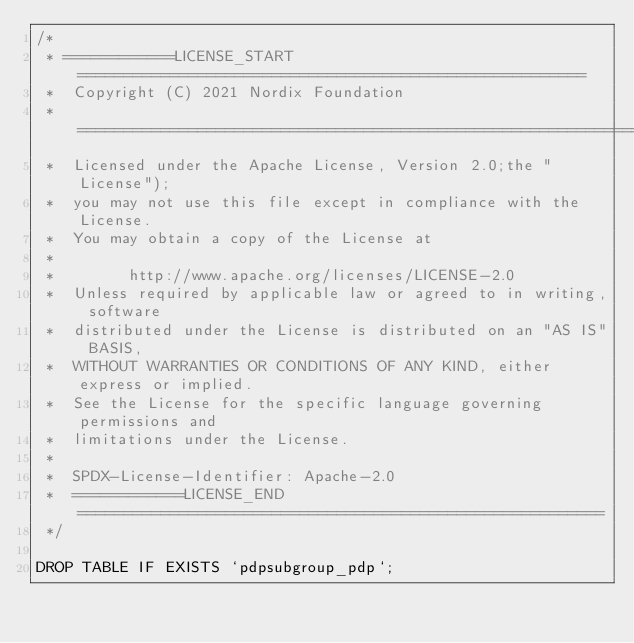Convert code to text. <code><loc_0><loc_0><loc_500><loc_500><_SQL_>/*
 * ============LICENSE_START=======================================================
 *  Copyright (C) 2021 Nordix Foundation
 *  ================================================================================
 *  Licensed under the Apache License, Version 2.0;the "License");
 *  you may not use this file except in compliance with the License.
 *  You may obtain a copy of the License at
 *
 *        http://www.apache.org/licenses/LICENSE-2.0
 *  Unless required by applicable law or agreed to in writing, software
 *  distributed under the License is distributed on an "AS IS" BASIS,
 *  WITHOUT WARRANTIES OR CONDITIONS OF ANY KIND, either express or implied.
 *  See the License for the specific language governing permissions and
 *  limitations under the License.
 *
 *  SPDX-License-Identifier: Apache-2.0
 *  ============LICENSE_END=========================================================
 */

DROP TABLE IF EXISTS `pdpsubgroup_pdp`;
</code> 